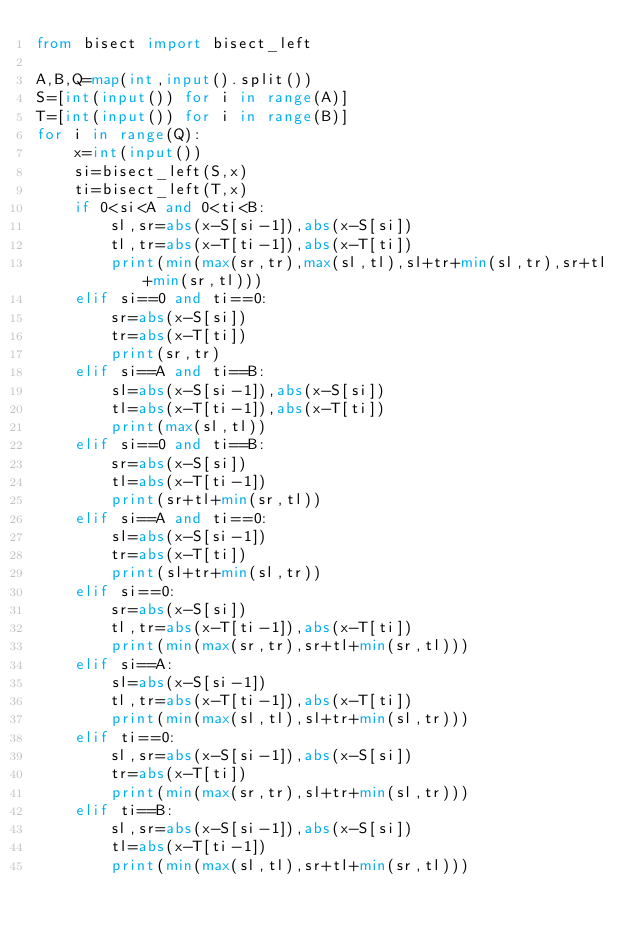Convert code to text. <code><loc_0><loc_0><loc_500><loc_500><_Python_>from bisect import bisect_left

A,B,Q=map(int,input().split())
S=[int(input()) for i in range(A)]
T=[int(input()) for i in range(B)]
for i in range(Q):
    x=int(input())
    si=bisect_left(S,x)
    ti=bisect_left(T,x)
    if 0<si<A and 0<ti<B:
        sl,sr=abs(x-S[si-1]),abs(x-S[si])
        tl,tr=abs(x-T[ti-1]),abs(x-T[ti])
        print(min(max(sr,tr),max(sl,tl),sl+tr+min(sl,tr),sr+tl+min(sr,tl)))
    elif si==0 and ti==0:
        sr=abs(x-S[si])
        tr=abs(x-T[ti])
        print(sr,tr)
    elif si==A and ti==B:
        sl=abs(x-S[si-1]),abs(x-S[si])
        tl=abs(x-T[ti-1]),abs(x-T[ti])
        print(max(sl,tl))
    elif si==0 and ti==B:
        sr=abs(x-S[si])
        tl=abs(x-T[ti-1])
        print(sr+tl+min(sr,tl))
    elif si==A and ti==0:
        sl=abs(x-S[si-1])
        tr=abs(x-T[ti])
        print(sl+tr+min(sl,tr))
    elif si==0:
        sr=abs(x-S[si])
        tl,tr=abs(x-T[ti-1]),abs(x-T[ti])
        print(min(max(sr,tr),sr+tl+min(sr,tl)))
    elif si==A:
        sl=abs(x-S[si-1])
        tl,tr=abs(x-T[ti-1]),abs(x-T[ti])
        print(min(max(sl,tl),sl+tr+min(sl,tr)))
    elif ti==0:
        sl,sr=abs(x-S[si-1]),abs(x-S[si])
        tr=abs(x-T[ti])
        print(min(max(sr,tr),sl+tr+min(sl,tr)))
    elif ti==B:
        sl,sr=abs(x-S[si-1]),abs(x-S[si])
        tl=abs(x-T[ti-1])
        print(min(max(sl,tl),sr+tl+min(sr,tl)))</code> 